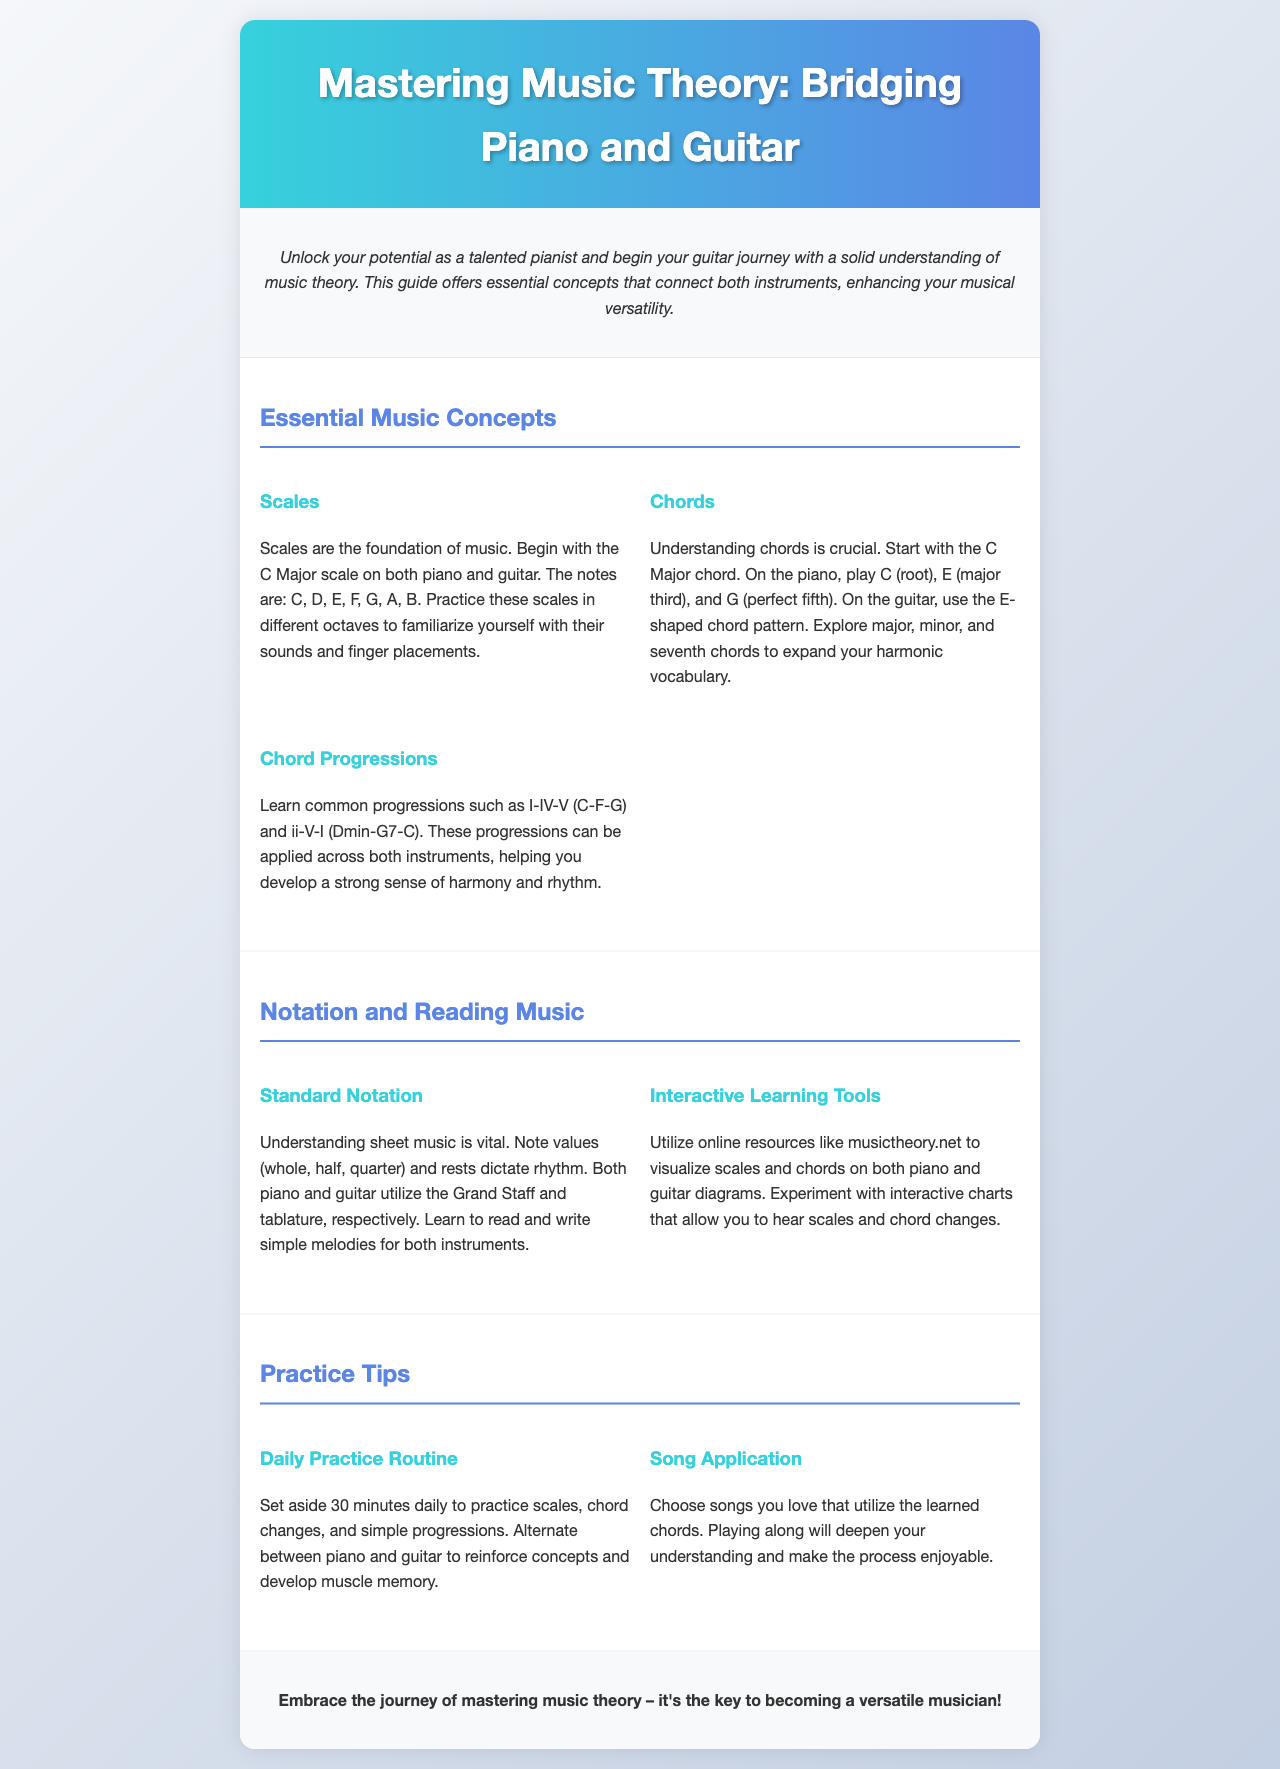What is the title of the brochure? The title is stated in the header of the document, which outlines the main focus of the content.
Answer: Mastering Music Theory: Bridging Piano and Guitar What is the first scale mentioned? The brochure refers to the C Major scale as the foundational scale for both instruments.
Answer: C Major What are the notes in the C Major scale? The document lists the specific notes included in the C Major scale for reference.
Answer: C, D, E, F, G, A, B Which chord is introduced first? The content specifies the C Major chord as the starting chord to learn understanding.
Answer: C Major What common chord progression is outlined? The brochure highlights a well-known chord progression that is essential for musical development.
Answer: I-IV-V (C-F-G) What is suggested for interactive learning? The brochure provides a resource recommendation to aid in understanding music theory visually and interactively.
Answer: musictheory.net How long should daily practice be? The document provides a specific duration for recommended daily practice to reinforce concepts learned.
Answer: 30 minutes What is emphasized as vital for understanding music? The brochure highlights a fundamental aspect that musicians need to grasp in order to play music effectively.
Answer: Sheet music Which technique is mentioned for applying learned chords? The content suggests applying knowledge by playing along with songs you love to enhance enjoyment.
Answer: Choose songs you love 